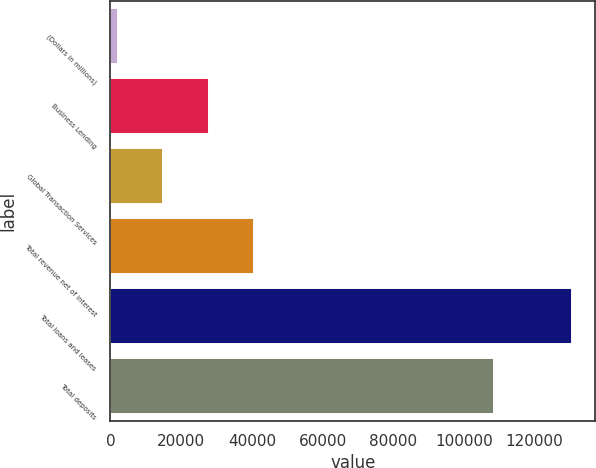Convert chart to OTSL. <chart><loc_0><loc_0><loc_500><loc_500><bar_chart><fcel>(Dollars in millions)<fcel>Business Lending<fcel>Global Transaction Services<fcel>Total revenue net of interest<fcel>Total loans and leases<fcel>Total deposits<nl><fcel>2013<fcel>27731.6<fcel>14872.3<fcel>40590.9<fcel>130606<fcel>108532<nl></chart> 